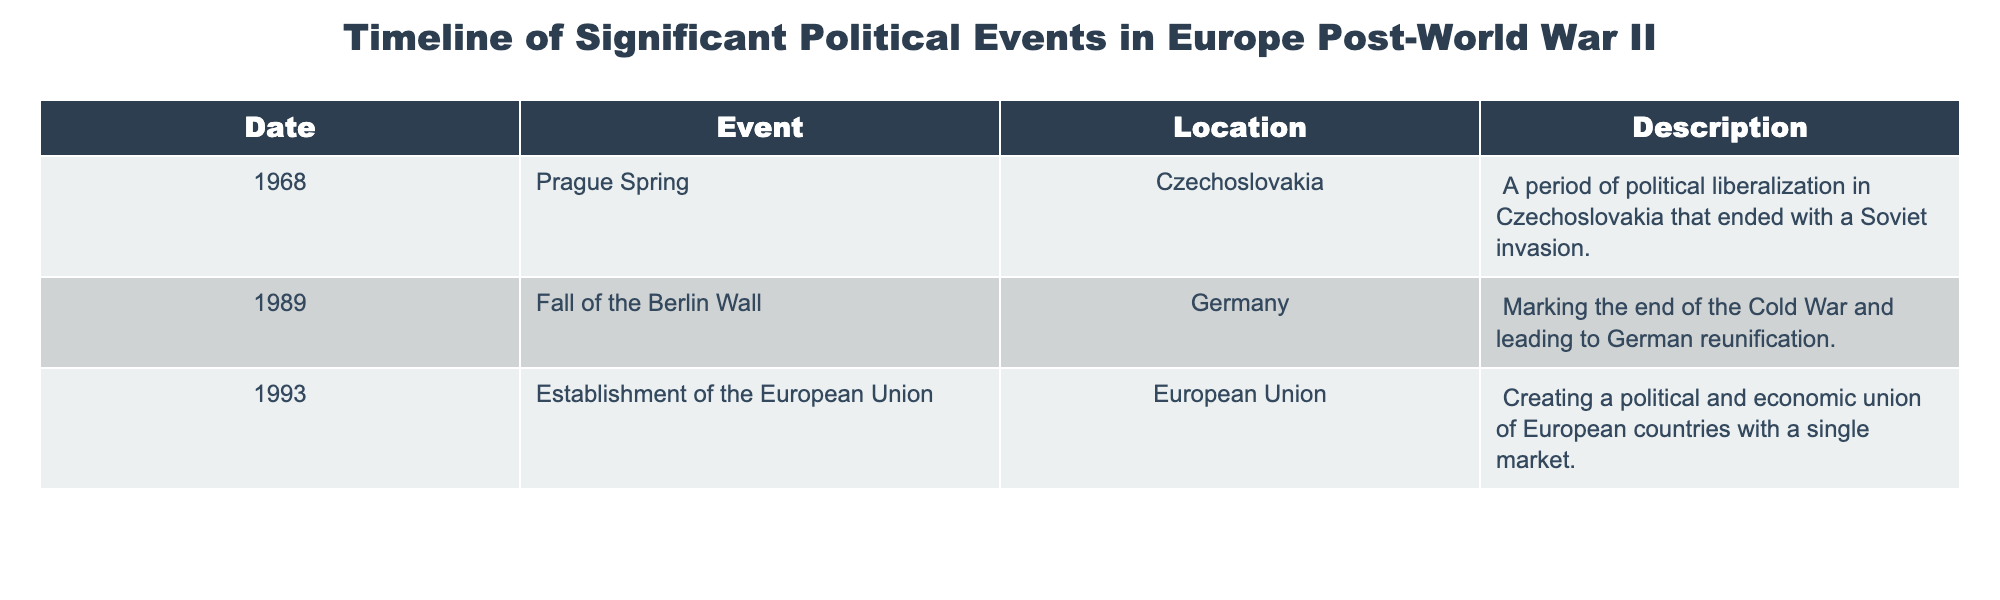What year did the Prague Spring occur? The Prague Spring is listed in the table under the "Date" column, and the corresponding year is noted as 1968.
Answer: 1968 What event is associated with the year 1989? The table lists the event next to the year 1989 as the "Fall of the Berlin Wall."
Answer: Fall of the Berlin Wall Was the establishment of the European Union in 1993? The table confirms that the establishment of the European Union is listed for the year 1993, which means the statement is true.
Answer: Yes How many significant events are listed in the table? By counting the number of rows in the table, there are three events listed. Therefore, the answer is three.
Answer: 3 Which event occurred first, the Prague Spring or the Fall of the Berlin Wall? The table indicates the Prague Spring occurred in 1968, while the Fall of the Berlin Wall occurred in 1989. Since 1968 comes before 1989, the Prague Spring was the first event.
Answer: Prague Spring What is the common theme of the events listed in the table? All the events listed in the table are significant political events in Europe occurring after World War II. They revolve around liberalization, reunification, and the establishment of a political union.
Answer: Political events in Europe post-World War II How many years separate the Fall of the Berlin Wall and the establishment of the European Union? The Fall of the Berlin Wall occurred in 1989, and the establishment of the European Union was in 1993. Calculating the difference, 1993 - 1989 equals 4 years.
Answer: 4 years Did a significant political event occur in Germany after 1989? The table mentions the Fall of the Berlin Wall, which was in Germany and happened in 1989. Therefore, the answer is true as it qualifies as a significant political event in Germany.
Answer: Yes What was the result of the Fall of the Berlin Wall? The table describes that the Fall of the Berlin Wall marked the end of the Cold War and led to German reunification, summarizing its significant outcome.
Answer: End of the Cold War and German reunification 